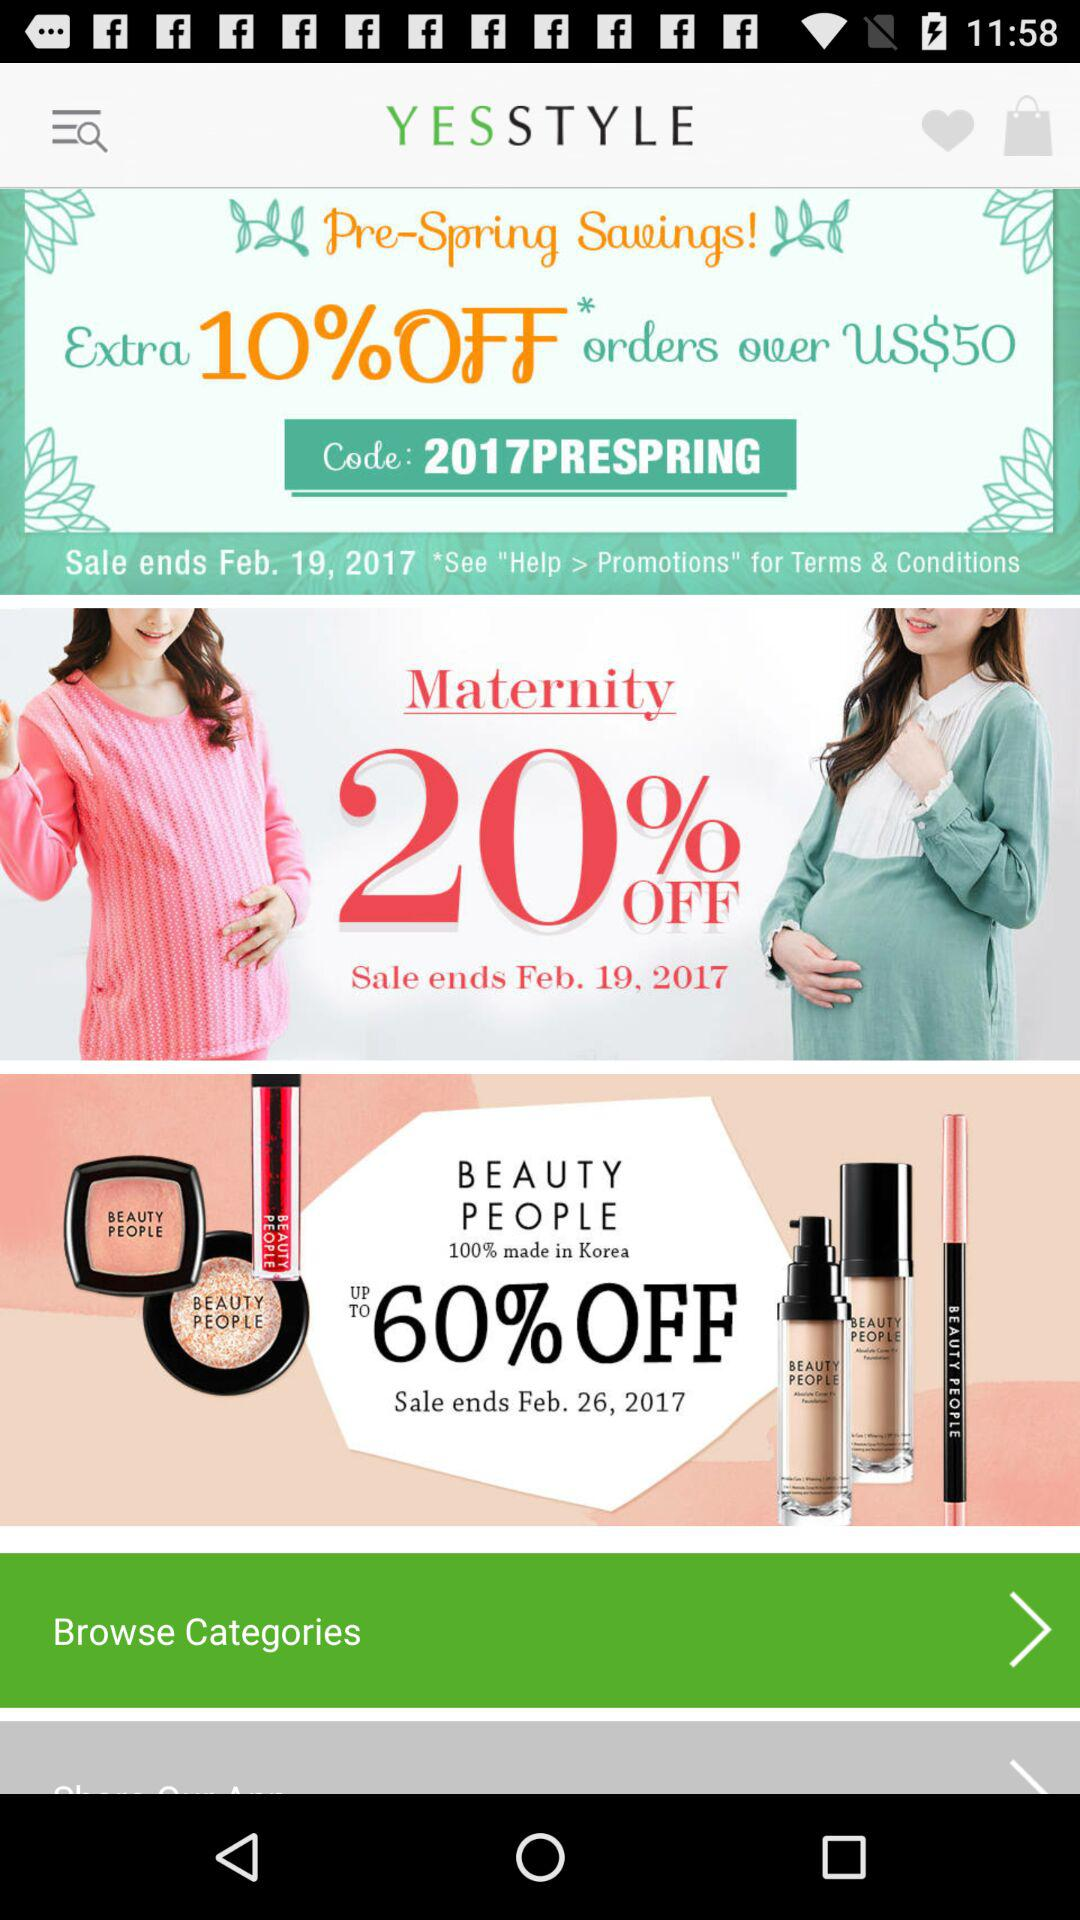How much of a discount is available on maternity products? The discount available on maternity products is 20%. 